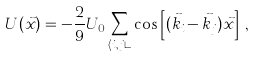Convert formula to latex. <formula><loc_0><loc_0><loc_500><loc_500>U ( \vec { x } ) = - \frac { 2 } { 9 } U _ { 0 } \sum _ { \langle i , j \rangle } \cos \left [ ( \vec { k } _ { i } - \vec { k } _ { j } ) \vec { x } \right ] \, ,</formula> 